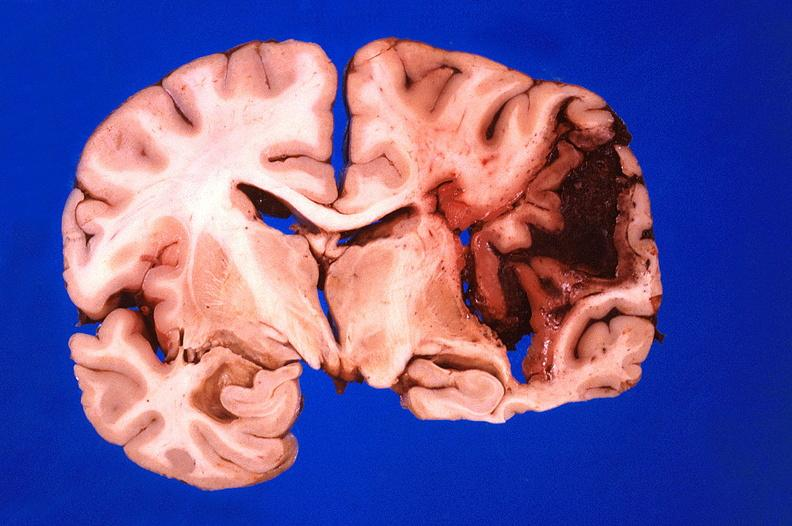does color show brain, hematoma due to ruptured aneurysm?
Answer the question using a single word or phrase. No 